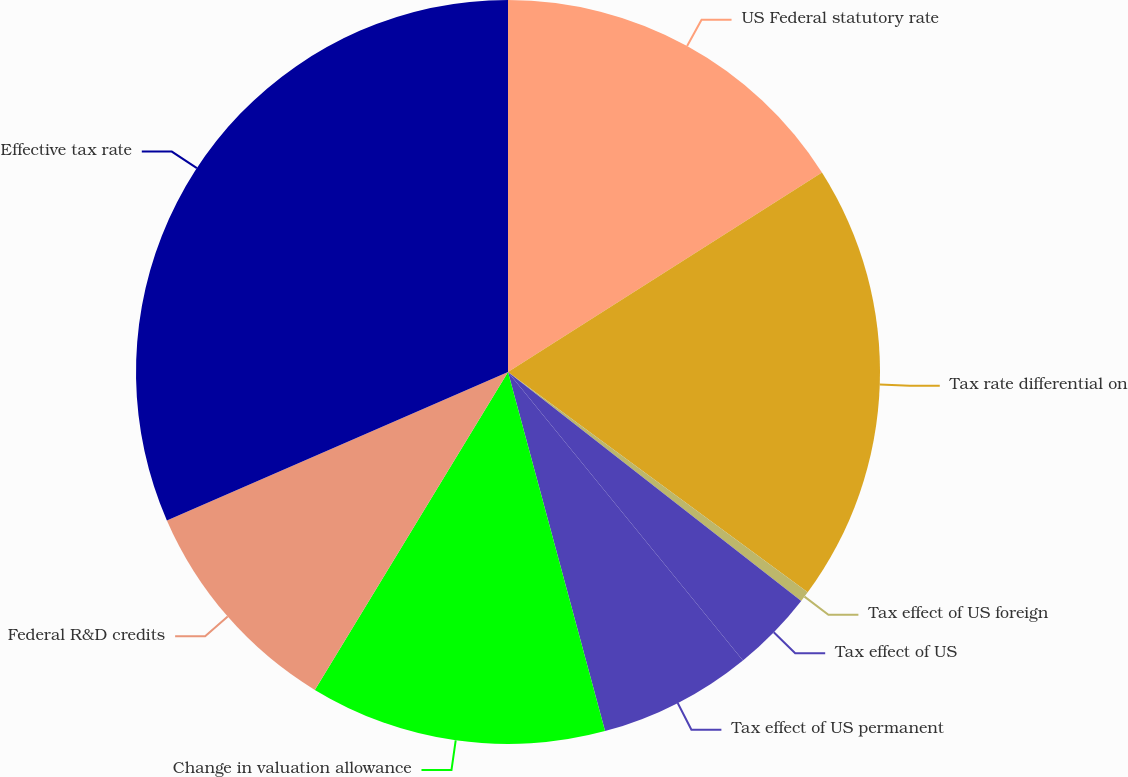Convert chart. <chart><loc_0><loc_0><loc_500><loc_500><pie_chart><fcel>US Federal statutory rate<fcel>Tax rate differential on<fcel>Tax effect of US foreign<fcel>Tax effect of US<fcel>Tax effect of US permanent<fcel>Change in valuation allowance<fcel>Federal R&D credits<fcel>Effective tax rate<nl><fcel>15.99%<fcel>19.1%<fcel>0.46%<fcel>3.57%<fcel>6.68%<fcel>12.89%<fcel>9.78%<fcel>31.53%<nl></chart> 